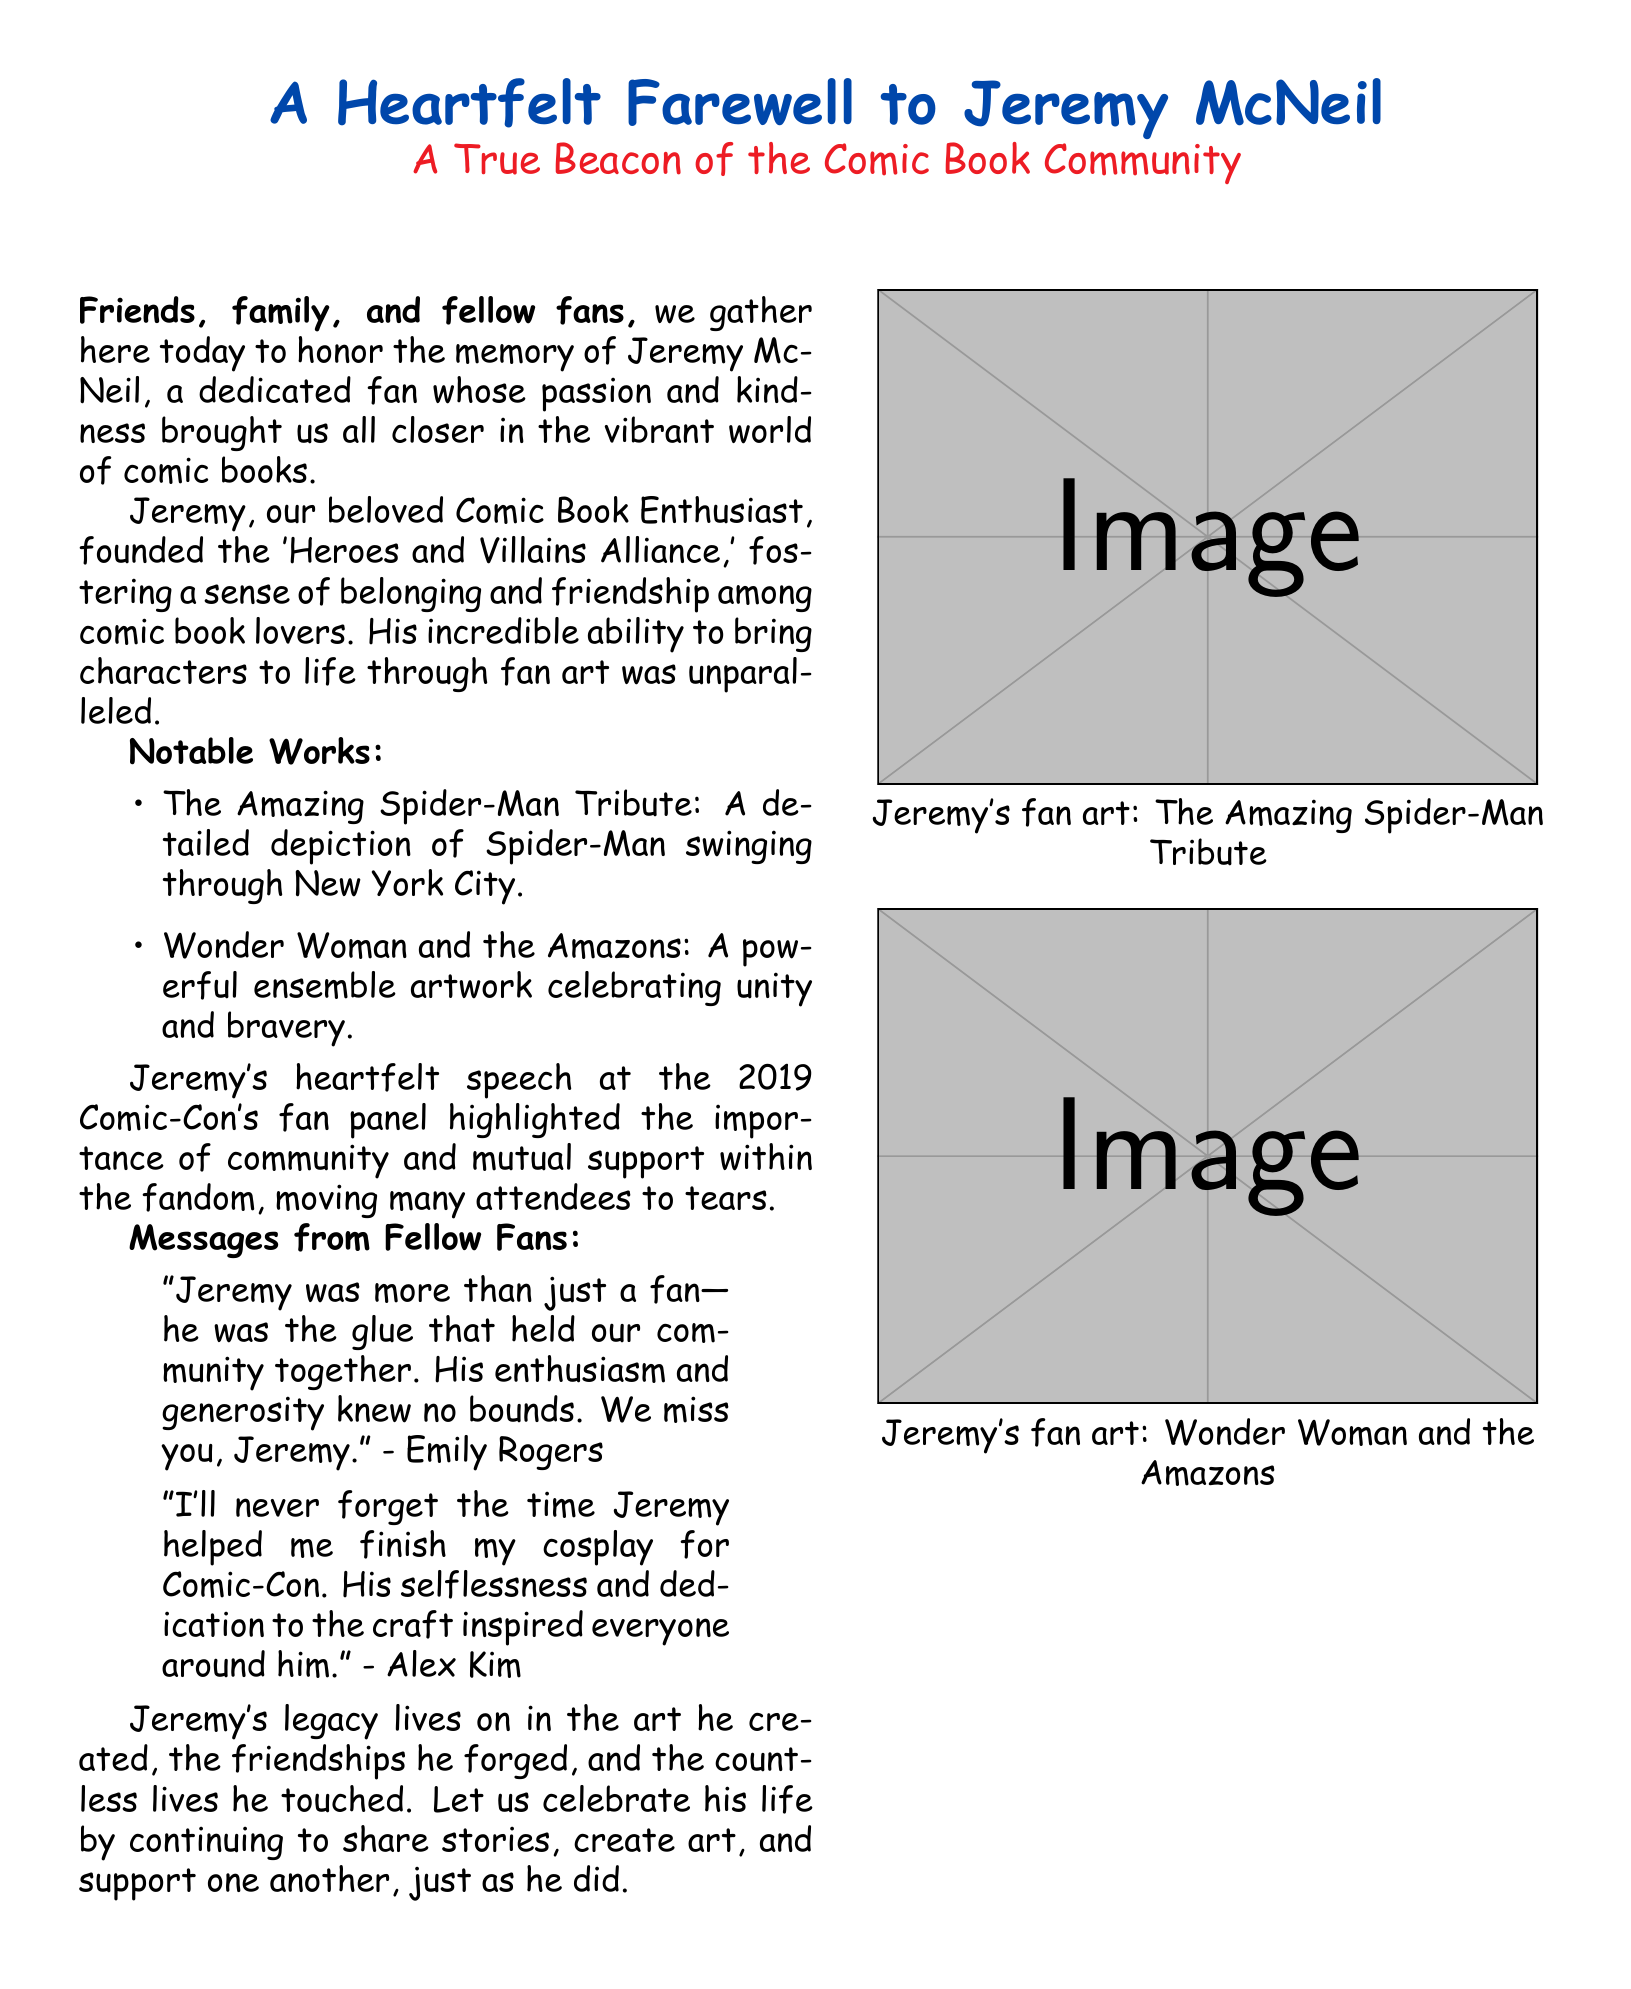What was Jeremy McNeil known for? Jeremy McNeil was known for his passion and kindness in the comic book community, especially in bringing fans together.
Answer: Passion and kindness What art piece featured Spider-Man? The document lists “The Amazing Spider-Man Tribute” as one of Jeremy's notable works.
Answer: The Amazing Spider-Man Tribute What was the name of the fan group he founded? Jeremy founded the 'Heroes and Villains Alliance'.
Answer: Heroes and Villains Alliance In what year did Jeremy give a memorable speech at Comic-Con? The document states that Jeremy gave a heartfelt speech in 2019.
Answer: 2019 Who described Jeremy as the "glue" of the community? Emily Rogers described Jeremy with this sentiment in her message.
Answer: Emily Rogers What type of artwork was included in the tribute? The document includes drawings such as tribute art for Spider-Man and Wonder Woman.
Answer: Tribute art for Spider-Man and Wonder Woman How did fellow fans view Jeremy's impact on their lives? Fellow fans expressed that Jeremy inspired and supported them, showcasing his selflessness.
Answer: Inspired and supported What does the eulogy encourage us to do in Jeremy's memory? The eulogy encourages sharing stories, creating art, and supporting each other.
Answer: Share stories, create art, support each other Which artwork depicts Wonder Woman? The artwork titled “Wonder Woman and the Amazons” depicts Wonder Woman.
Answer: Wonder Woman and the Amazons 